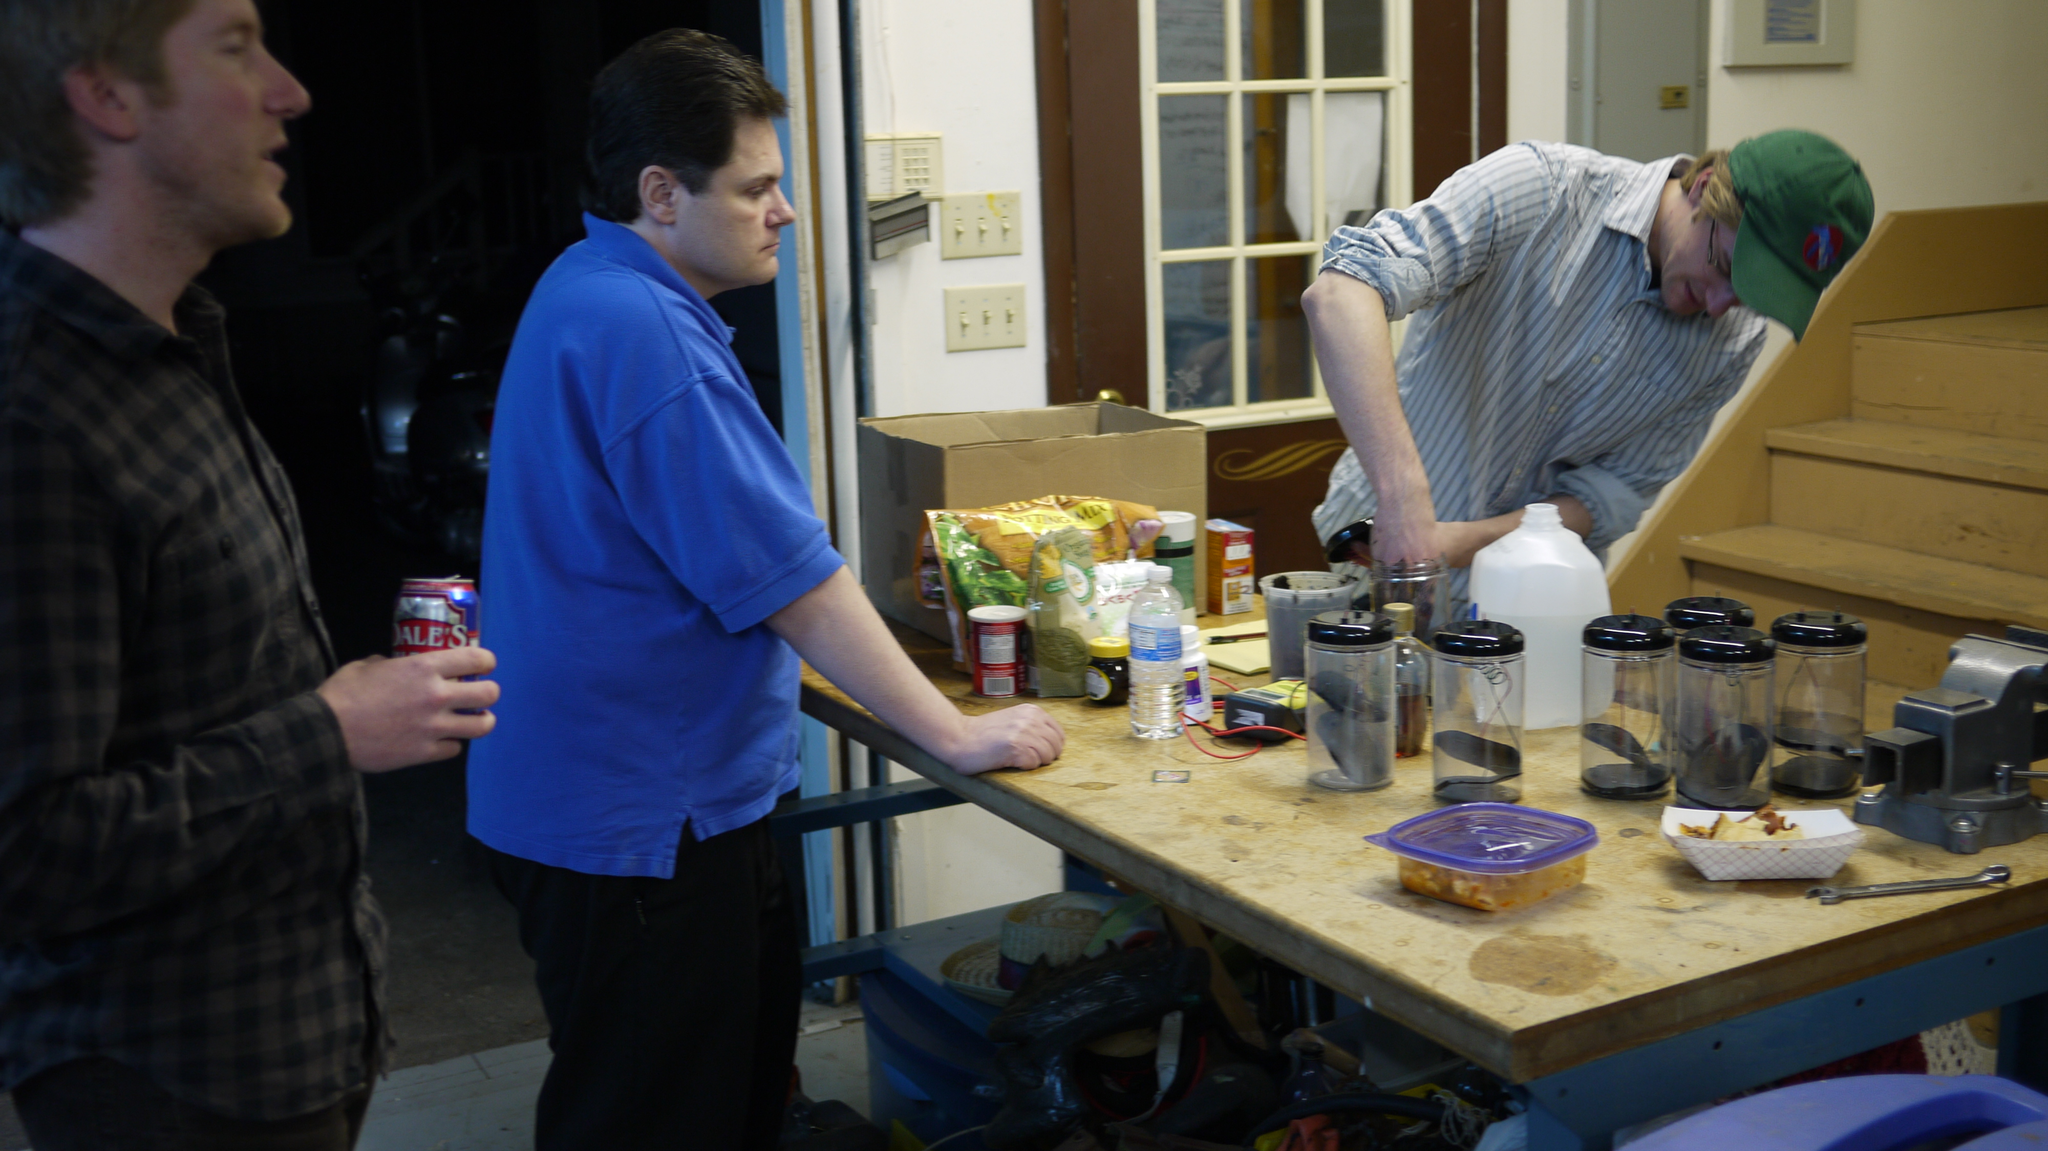How would you summarize this image in a sentence or two? This picture describes about three people, in the left side of the given image a person is holding a tin in his hands in front of them we can see bottles, food and boxes on the table. In the right side of the given image a man is wearing a cap. 